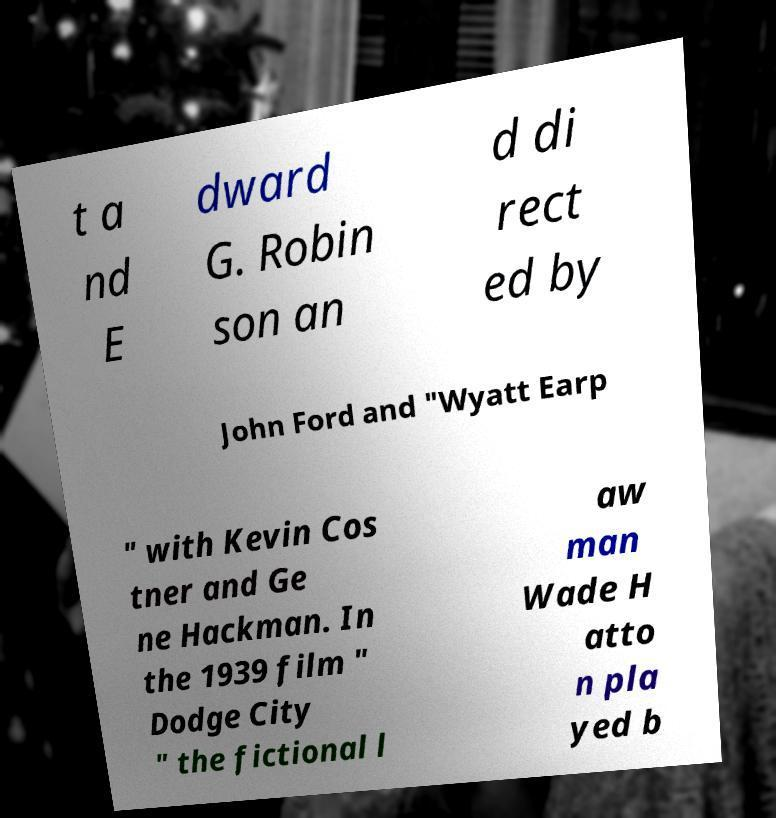I need the written content from this picture converted into text. Can you do that? t a nd E dward G. Robin son an d di rect ed by John Ford and "Wyatt Earp " with Kevin Cos tner and Ge ne Hackman. In the 1939 film " Dodge City " the fictional l aw man Wade H atto n pla yed b 